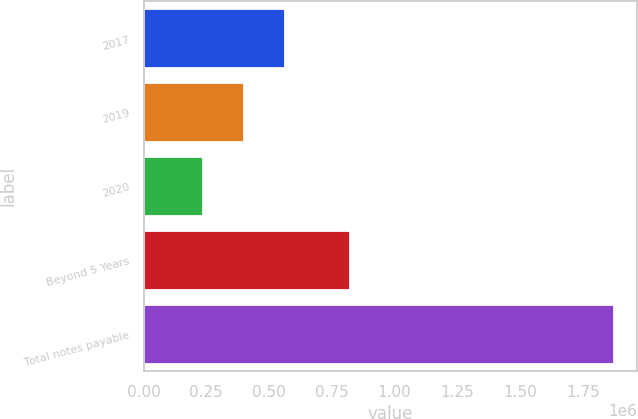<chart> <loc_0><loc_0><loc_500><loc_500><bar_chart><fcel>2017<fcel>2019<fcel>2020<fcel>Beyond 5 Years<fcel>Total notes payable<nl><fcel>564893<fcel>401445<fcel>237997<fcel>820601<fcel>1.87248e+06<nl></chart> 